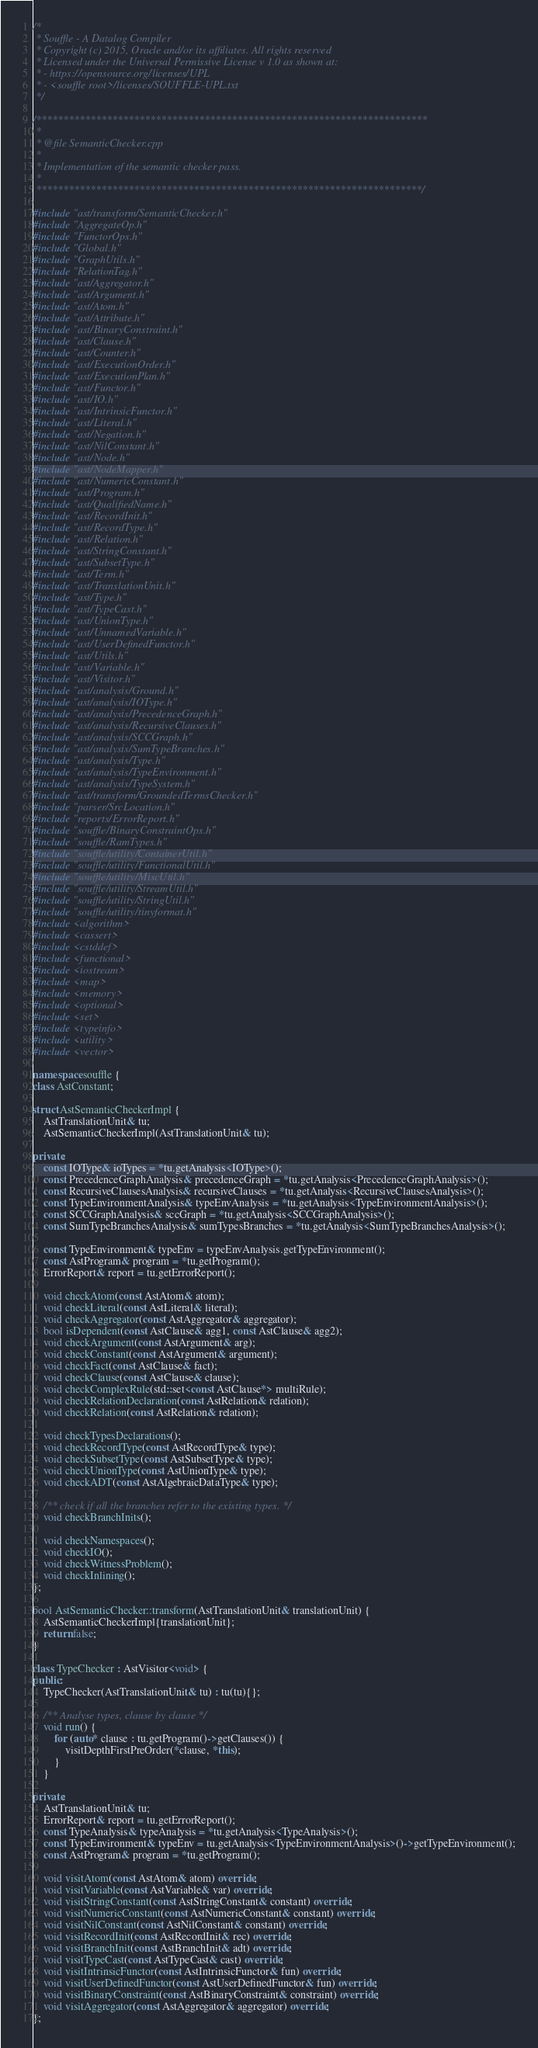<code> <loc_0><loc_0><loc_500><loc_500><_C++_>/*
 * Souffle - A Datalog Compiler
 * Copyright (c) 2015, Oracle and/or its affiliates. All rights reserved
 * Licensed under the Universal Permissive License v 1.0 as shown at:
 * - https://opensource.org/licenses/UPL
 * - <souffle root>/licenses/SOUFFLE-UPL.txt
 */

/************************************************************************
 *
 * @file SemanticChecker.cpp
 *
 * Implementation of the semantic checker pass.
 *
 ***********************************************************************/

#include "ast/transform/SemanticChecker.h"
#include "AggregateOp.h"
#include "FunctorOps.h"
#include "Global.h"
#include "GraphUtils.h"
#include "RelationTag.h"
#include "ast/Aggregator.h"
#include "ast/Argument.h"
#include "ast/Atom.h"
#include "ast/Attribute.h"
#include "ast/BinaryConstraint.h"
#include "ast/Clause.h"
#include "ast/Counter.h"
#include "ast/ExecutionOrder.h"
#include "ast/ExecutionPlan.h"
#include "ast/Functor.h"
#include "ast/IO.h"
#include "ast/IntrinsicFunctor.h"
#include "ast/Literal.h"
#include "ast/Negation.h"
#include "ast/NilConstant.h"
#include "ast/Node.h"
#include "ast/NodeMapper.h"
#include "ast/NumericConstant.h"
#include "ast/Program.h"
#include "ast/QualifiedName.h"
#include "ast/RecordInit.h"
#include "ast/RecordType.h"
#include "ast/Relation.h"
#include "ast/StringConstant.h"
#include "ast/SubsetType.h"
#include "ast/Term.h"
#include "ast/TranslationUnit.h"
#include "ast/Type.h"
#include "ast/TypeCast.h"
#include "ast/UnionType.h"
#include "ast/UnnamedVariable.h"
#include "ast/UserDefinedFunctor.h"
#include "ast/Utils.h"
#include "ast/Variable.h"
#include "ast/Visitor.h"
#include "ast/analysis/Ground.h"
#include "ast/analysis/IOType.h"
#include "ast/analysis/PrecedenceGraph.h"
#include "ast/analysis/RecursiveClauses.h"
#include "ast/analysis/SCCGraph.h"
#include "ast/analysis/SumTypeBranches.h"
#include "ast/analysis/Type.h"
#include "ast/analysis/TypeEnvironment.h"
#include "ast/analysis/TypeSystem.h"
#include "ast/transform/GroundedTermsChecker.h"
#include "parser/SrcLocation.h"
#include "reports/ErrorReport.h"
#include "souffle/BinaryConstraintOps.h"
#include "souffle/RamTypes.h"
#include "souffle/utility/ContainerUtil.h"
#include "souffle/utility/FunctionalUtil.h"
#include "souffle/utility/MiscUtil.h"
#include "souffle/utility/StreamUtil.h"
#include "souffle/utility/StringUtil.h"
#include "souffle/utility/tinyformat.h"
#include <algorithm>
#include <cassert>
#include <cstddef>
#include <functional>
#include <iostream>
#include <map>
#include <memory>
#include <optional>
#include <set>
#include <typeinfo>
#include <utility>
#include <vector>

namespace souffle {
class AstConstant;

struct AstSemanticCheckerImpl {
    AstTranslationUnit& tu;
    AstSemanticCheckerImpl(AstTranslationUnit& tu);

private:
    const IOType& ioTypes = *tu.getAnalysis<IOType>();
    const PrecedenceGraphAnalysis& precedenceGraph = *tu.getAnalysis<PrecedenceGraphAnalysis>();
    const RecursiveClausesAnalysis& recursiveClauses = *tu.getAnalysis<RecursiveClausesAnalysis>();
    const TypeEnvironmentAnalysis& typeEnvAnalysis = *tu.getAnalysis<TypeEnvironmentAnalysis>();
    const SCCGraphAnalysis& sccGraph = *tu.getAnalysis<SCCGraphAnalysis>();
    const SumTypeBranchesAnalysis& sumTypesBranches = *tu.getAnalysis<SumTypeBranchesAnalysis>();

    const TypeEnvironment& typeEnv = typeEnvAnalysis.getTypeEnvironment();
    const AstProgram& program = *tu.getProgram();
    ErrorReport& report = tu.getErrorReport();

    void checkAtom(const AstAtom& atom);
    void checkLiteral(const AstLiteral& literal);
    void checkAggregator(const AstAggregator& aggregator);
    bool isDependent(const AstClause& agg1, const AstClause& agg2);
    void checkArgument(const AstArgument& arg);
    void checkConstant(const AstArgument& argument);
    void checkFact(const AstClause& fact);
    void checkClause(const AstClause& clause);
    void checkComplexRule(std::set<const AstClause*> multiRule);
    void checkRelationDeclaration(const AstRelation& relation);
    void checkRelation(const AstRelation& relation);

    void checkTypesDeclarations();
    void checkRecordType(const AstRecordType& type);
    void checkSubsetType(const AstSubsetType& type);
    void checkUnionType(const AstUnionType& type);
    void checkADT(const AstAlgebraicDataType& type);

    /** check if all the branches refer to the existing types. */
    void checkBranchInits();

    void checkNamespaces();
    void checkIO();
    void checkWitnessProblem();
    void checkInlining();
};

bool AstSemanticChecker::transform(AstTranslationUnit& translationUnit) {
    AstSemanticCheckerImpl{translationUnit};
    return false;
}

class TypeChecker : AstVisitor<void> {
public:
    TypeChecker(AstTranslationUnit& tu) : tu(tu){};

    /** Analyse types, clause by clause */
    void run() {
        for (auto* clause : tu.getProgram()->getClauses()) {
            visitDepthFirstPreOrder(*clause, *this);
        }
    }

private:
    AstTranslationUnit& tu;
    ErrorReport& report = tu.getErrorReport();
    const TypeAnalysis& typeAnalysis = *tu.getAnalysis<TypeAnalysis>();
    const TypeEnvironment& typeEnv = tu.getAnalysis<TypeEnvironmentAnalysis>()->getTypeEnvironment();
    const AstProgram& program = *tu.getProgram();

    void visitAtom(const AstAtom& atom) override;
    void visitVariable(const AstVariable& var) override;
    void visitStringConstant(const AstStringConstant& constant) override;
    void visitNumericConstant(const AstNumericConstant& constant) override;
    void visitNilConstant(const AstNilConstant& constant) override;
    void visitRecordInit(const AstRecordInit& rec) override;
    void visitBranchInit(const AstBranchInit& adt) override;
    void visitTypeCast(const AstTypeCast& cast) override;
    void visitIntrinsicFunctor(const AstIntrinsicFunctor& fun) override;
    void visitUserDefinedFunctor(const AstUserDefinedFunctor& fun) override;
    void visitBinaryConstraint(const AstBinaryConstraint& constraint) override;
    void visitAggregator(const AstAggregator& aggregator) override;
};
</code> 